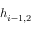<formula> <loc_0><loc_0><loc_500><loc_500>h _ { i - 1 , 2 }</formula> 